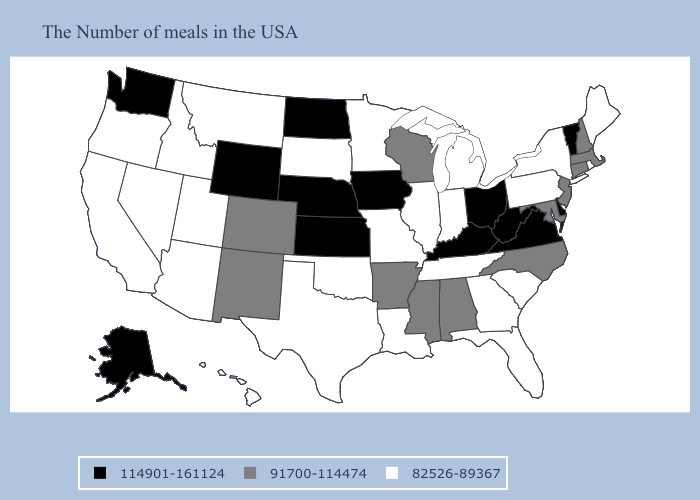What is the value of Missouri?
Write a very short answer. 82526-89367. Does Illinois have a higher value than Oregon?
Give a very brief answer. No. Does Hawaii have the highest value in the West?
Short answer required. No. What is the value of South Carolina?
Be succinct. 82526-89367. Name the states that have a value in the range 91700-114474?
Concise answer only. Massachusetts, New Hampshire, Connecticut, New Jersey, Maryland, North Carolina, Alabama, Wisconsin, Mississippi, Arkansas, Colorado, New Mexico. What is the value of Colorado?
Short answer required. 91700-114474. Among the states that border Mississippi , does Louisiana have the lowest value?
Short answer required. Yes. Name the states that have a value in the range 82526-89367?
Keep it brief. Maine, Rhode Island, New York, Pennsylvania, South Carolina, Florida, Georgia, Michigan, Indiana, Tennessee, Illinois, Louisiana, Missouri, Minnesota, Oklahoma, Texas, South Dakota, Utah, Montana, Arizona, Idaho, Nevada, California, Oregon, Hawaii. Among the states that border Nebraska , which have the lowest value?
Quick response, please. Missouri, South Dakota. What is the value of Kentucky?
Keep it brief. 114901-161124. Does the first symbol in the legend represent the smallest category?
Keep it brief. No. Does Indiana have the highest value in the MidWest?
Short answer required. No. Does Maryland have a lower value than Michigan?
Concise answer only. No. Name the states that have a value in the range 91700-114474?
Be succinct. Massachusetts, New Hampshire, Connecticut, New Jersey, Maryland, North Carolina, Alabama, Wisconsin, Mississippi, Arkansas, Colorado, New Mexico. What is the value of Pennsylvania?
Give a very brief answer. 82526-89367. 